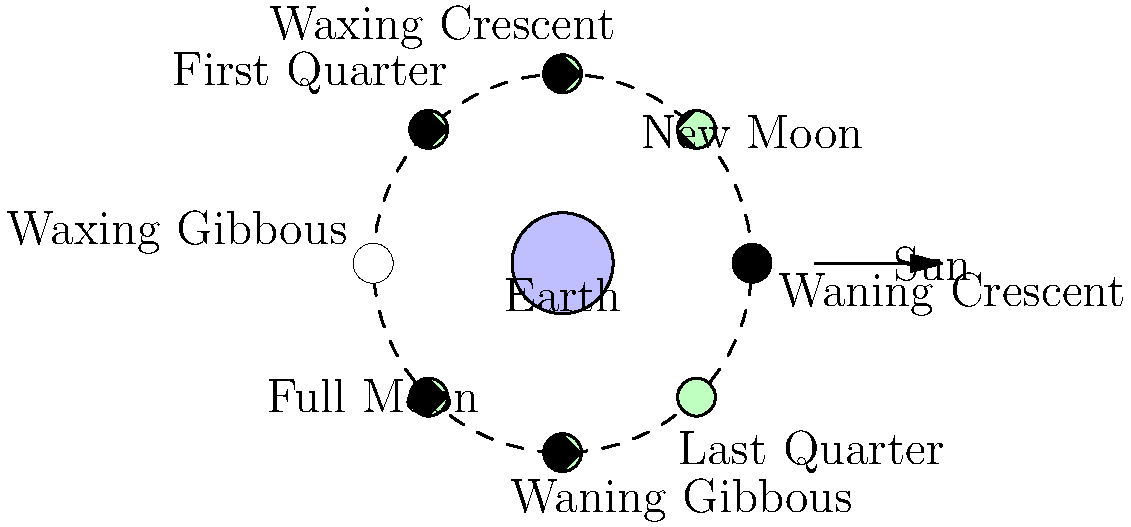In the northern hemisphere, which phase of the Moon would be visible shortly after sunset, appearing as a bright crescent in the western sky? To answer this question, we need to understand how the Moon's phases work and how they appear from Earth:

1. The Moon orbits around the Earth, and the Earth orbits around the Sun.
2. The Moon's phases are determined by the relative positions of the Sun, Earth, and Moon.
3. The illuminated portion of the Moon that we see from Earth changes as the Moon moves through its orbit.
4. In the northern hemisphere, the Moon's phases progress from right to left as viewed from Earth.

Now, let's consider the scenario:
5. Shortly after sunset, the Sun has just disappeared below the western horizon.
6. For a crescent Moon to be visible in the western sky at this time, it must be slightly east of the Sun in its orbit.
7. This position corresponds to the Waxing Crescent phase.
8. In this phase, a small portion of the Moon's illuminated surface is visible from Earth, appearing as a crescent shape.
9. The Waxing Crescent follows the New Moon phase and precedes the First Quarter phase.

Therefore, the phase of the Moon visible shortly after sunset in the western sky, appearing as a bright crescent, would be the Waxing Crescent.
Answer: Waxing Crescent 